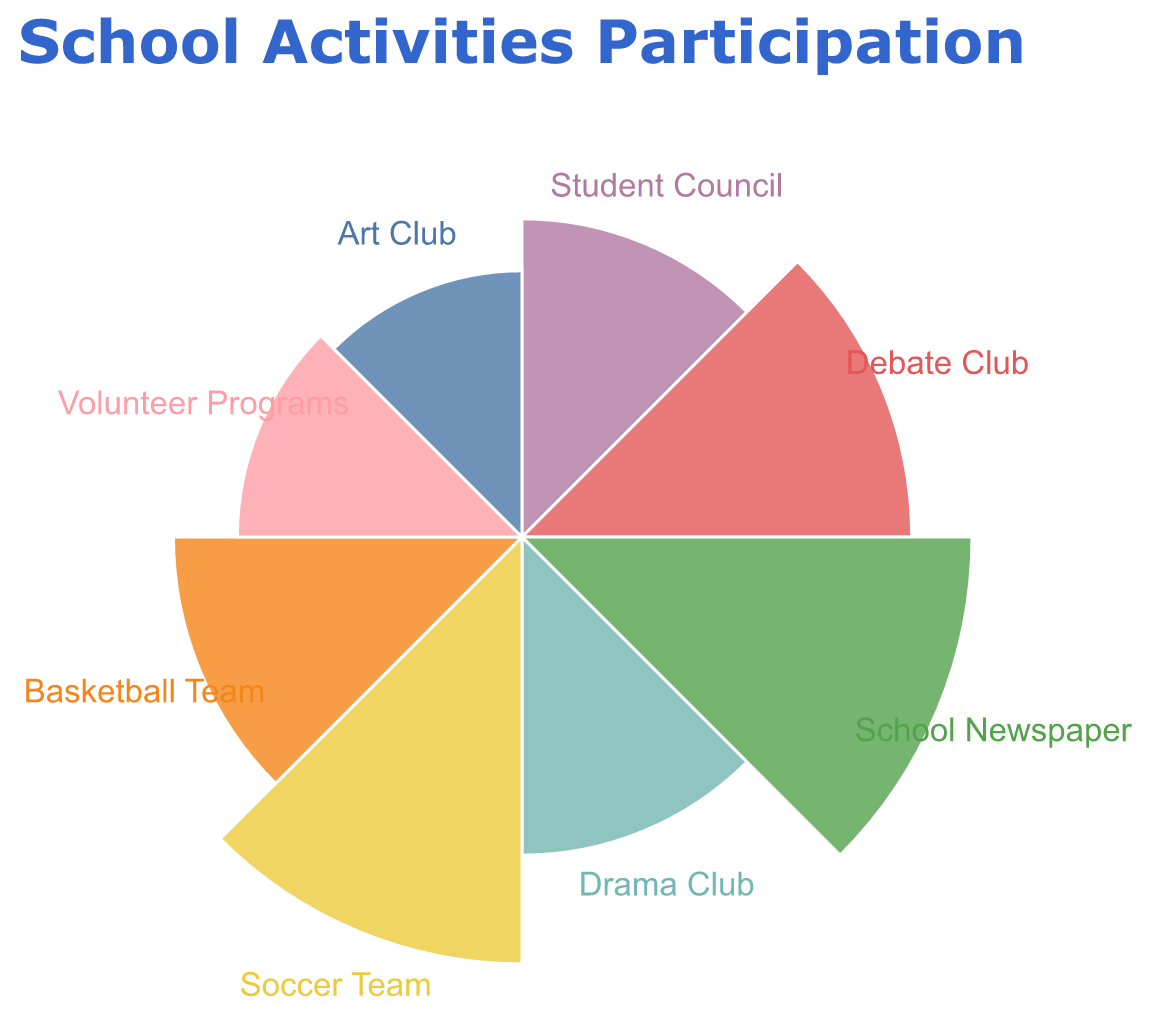What is the title of the chart? The title of the chart is displayed at the top of the figure and reads "School Activities Participation".
Answer: School Activities Participation How many categories are displayed in the chart? By counting the different labeled segments within the chart, there are a total of 8 categories displayed.
Answer: 8 Which category has the highest participation percentage? The category with the largest arc and radius indicating the highest participation percentage is 'School Newspaper' with 20%.
Answer: School Newspaper Which two categories have the same participation percentage? Both 'Student Council' and 'Drama Club' have arcs of equal size and radius, each representing a participation percentage of 10%.
Answer: Student Council, Drama Club What is the combined participation percentage of the sports-related activities? By adding the participation percentages of 'Soccer Team' (18%) and 'Basketball Team' (12%), the combined participation percentage is 18 + 12 = 30%.
Answer: 30% How much larger is the participation percentage of the School Newspaper compared to the Art Club? The participation percentage of the School Newspaper is 20%, and the Art Club is 7%. The difference is 20 - 7 = 13%.
Answer: 13% Which category has the lowest participation percentage? The category 'Art Club' has the smallest arc and radius, indicating the lowest participation percentage of 7%.
Answer: Art Club What is the average participation percentage of all categories? To find the average, sum all percentages and divide by the number of categories. Total is 10+15+20+10+18+12+8+7 = 100%, divided by 8 categories is 100/8 = 12.5%.
Answer: 12.5% Which has a higher participation percentage, Soccer Team or Basketball Team? The participation percentage of the Soccer Team is 18%, which is higher than the Basketball Team's 12%.
Answer: Soccer Team Apart from the sports categories, which other category has a participation percentage higher than 10%? Excluding 'Soccer Team' (18%) and 'Basketball Team' (12%), the other category with a percentage higher than 10% is 'School Newspaper' with 20% and 'Debate Club' with 15%.
Answer: School Newspaper, Debate Club 